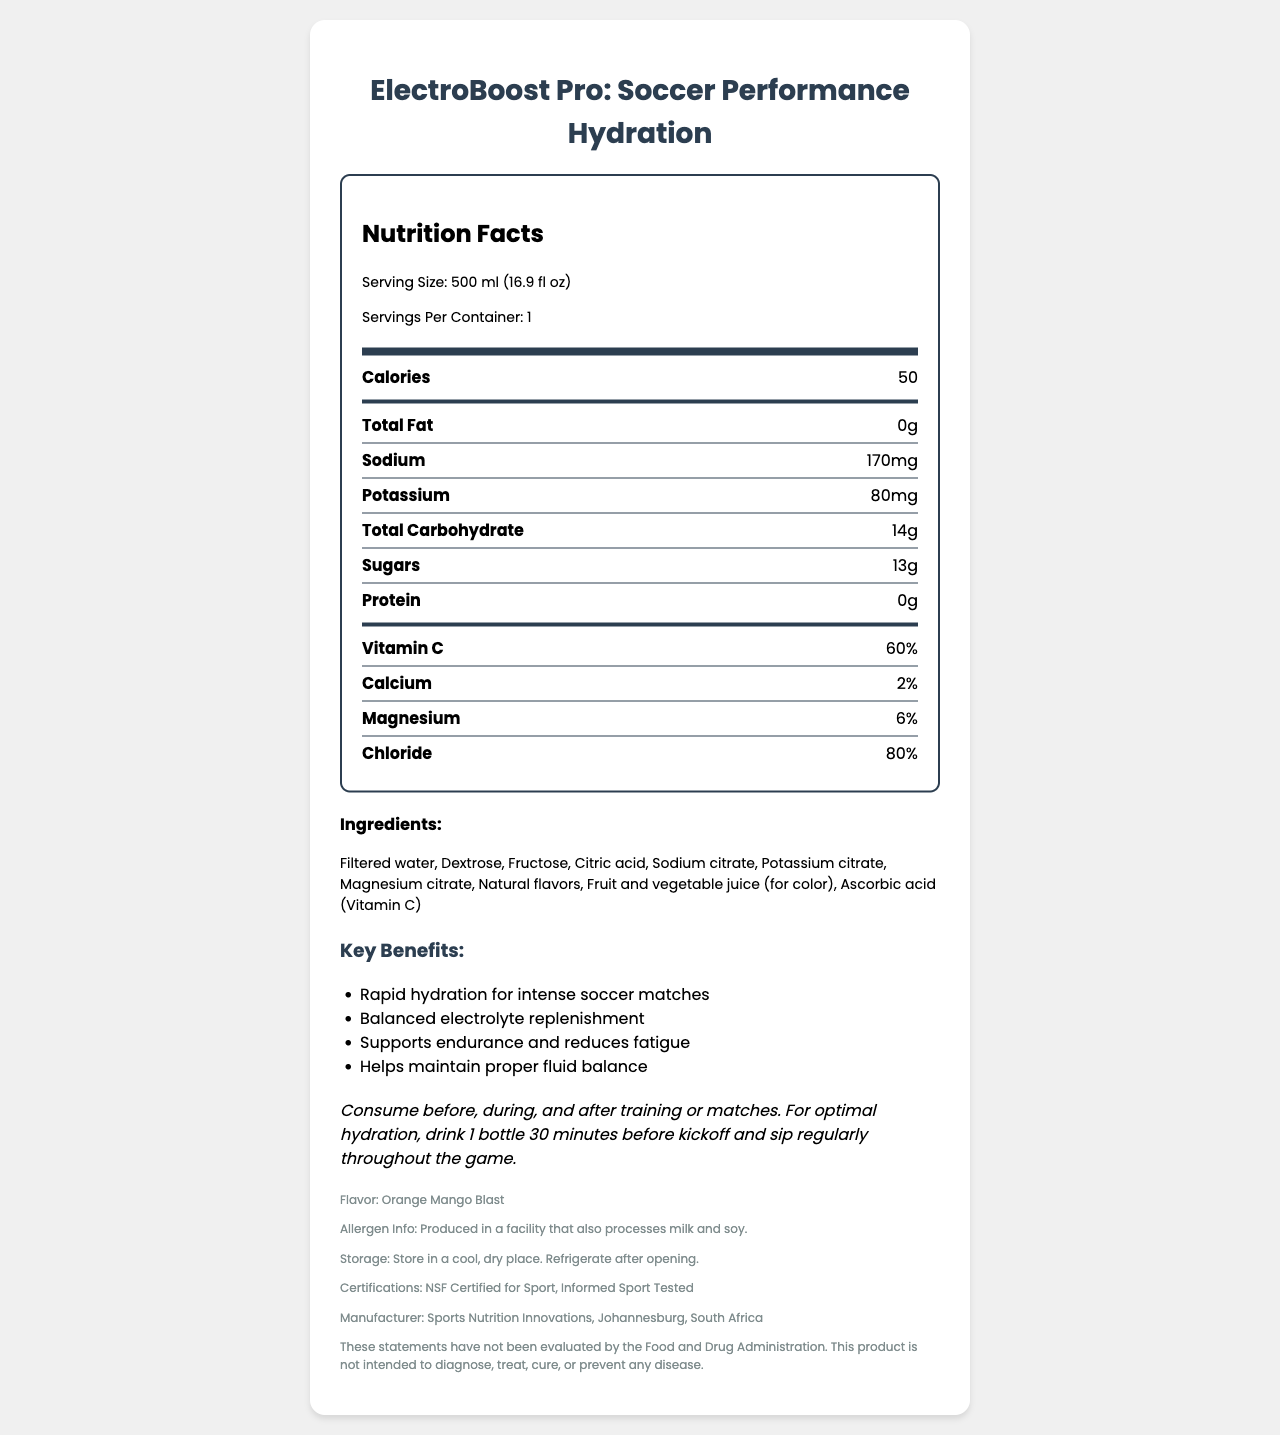What is the serving size of ElectroBoost Pro? The serving size is mentioned at the top of the nutrition facts label under the "Serving Size" section.
Answer: 500 ml (16.9 fl oz) How many servings are there per container? The number of servings per container is stated under the "Servings Per Container" section of the nutrition facts label.
Answer: 1 How many calories does one serving of ElectroBoost Pro contain? The caloric content per serving is listed as 50 calories under the "Calories" section of the nutrition facts.
Answer: 50 What is the amount of sodium in ElectroBoost Pro per serving? The sodium content per serving is shown as 170 mg in the nutrition facts label.
Answer: 170 mg Which electrolytes are listed in the nutrition facts? A. Potassium, Sodium, Magnesium B. Sodium, Calcium, Zinc C. Magnesium, Sodium, Iron D. Calcium, Magnesium, Phosphorus Potassium, Sodium, and Magnesium are listed under the nutrient rows section in the nutrition facts.
Answer: A. Potassium, Sodium, Magnesium How much sugar does ElectroBoost Pro contain per serving? The amount of sugar is listed as 13 g under the "Sugars" section of the nutrition facts.
Answer: 13 g What flavor is ElectroBoost Pro? The flavor of ElectroBoost Pro is mentioned at the end of the document under the "Flavor" section.
Answer: Orange Mango Blast Is there any protein in ElectroBoost Pro? The protein content is listed as 0 g in the nutrition facts section.
Answer: No Which certifications does ElectroBoost Pro have? A. USDA Organic, FDA Approved B. NSF Certified for Sport, Informed Sport Tested C. Non-GMO, Gluten-Free D. Halal, Kosher The certifications are mentioned towards the end of the document, indicating it has "NSF Certified for Sport" and is "Informed Sport Tested".
Answer: B. NSF Certified for Sport, Informed Sport Tested Should ElectroBoost Pro be refrigerated after opening? The storage instructions at the end of the document state that it should be refrigerated after opening.
Answer: Yes What are the key benefits of ElectroBoost Pro? The key benefits are listed in the key benefits section of the document.
Answer: Rapid hydration for intense soccer matches, Balanced electrolyte replenishment, Supports endurance and reduces fatigue, Helps maintain proper fluid balance What kind of juice is used for color in ElectroBoost Pro? The ingredient list includes "Fruit and vegetable juice (for color)".
Answer: Fruit and vegetable juice When should you consume ElectroBoost Pro for optimal performance? The usage instructions detail when and how to consume ElectroBoost Pro for optimal performance.
Answer: Before, during, and after training or matches. Drink 1 bottle 30 minutes before kickoff and sip regularly throughout the game. Is ElectroBoost Pro free from allergens? The allergen information states that it is produced in a facility that also processes milk and soy, which suggests potential cross-contamination.
Answer: No Describe the main idea of the ElectroBoost Pro nutrition facts document. The document serves to inform the reader about the nutritional value and use of ElectroBoost Pro for soccer players, focusing on its composition, benefits, and optimal usage to enhance athletic performance.
Answer: The document provides detailed nutritional information and benefits of the "ElectroBoost Pro: Soccer Performance Hydration" drink. It includes serving size, calorie content, and amounts of electrolytes like sodium, potassium, and magnesium. Additionally, it lists the ingredients, key benefits, usage instructions, allergen information, storage directions, certifications, and manufacturer details, emphasizing its suitability for enhancing soccer performance through rapid hydration and balanced electrolyte replenishment. Who is the manufacturer of ElectroBoost Pro? The manufacturer's information is provided at the end under the manufacturer section.
Answer: Sports Nutrition Innovations, Johannesburg, South Africa What percentage of Vitamin C is in each serving of ElectroBoost Pro? The Vitamin C content is listed as 60% in the nutrient rows of the nutrition facts.
Answer: 60% What are the allergens mentioned for ElectroBoost Pro? The allergen information states it is produced in a facility that processes milk and soy.
Answer: Milk and soy Why is dextrose included in ElectroBoost Pro? The document lists dextrose as an ingredient but does not explain why it is included.
Answer: Cannot be determined 